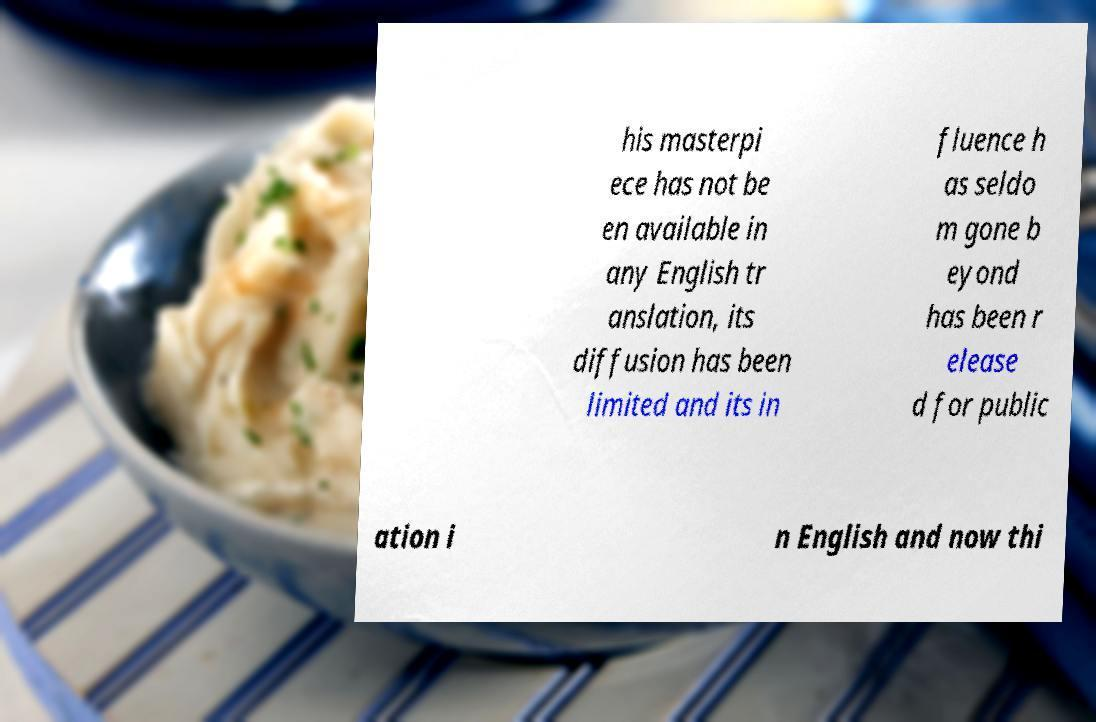Could you assist in decoding the text presented in this image and type it out clearly? his masterpi ece has not be en available in any English tr anslation, its diffusion has been limited and its in fluence h as seldo m gone b eyond has been r elease d for public ation i n English and now thi 